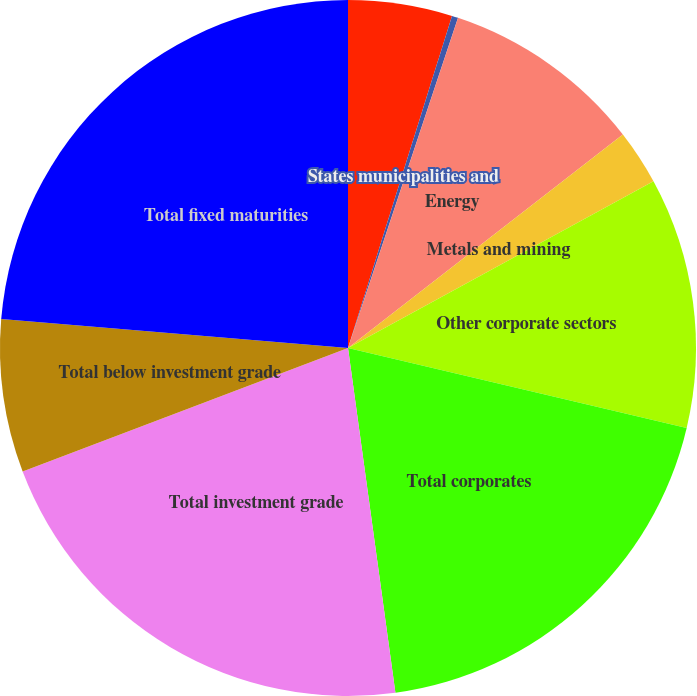Convert chart. <chart><loc_0><loc_0><loc_500><loc_500><pie_chart><fcel>US Government direct<fcel>States municipalities and<fcel>Energy<fcel>Metals and mining<fcel>Other corporate sectors<fcel>Total corporates<fcel>Total investment grade<fcel>Total below investment grade<fcel>Total fixed maturities<nl><fcel>4.83%<fcel>0.29%<fcel>9.37%<fcel>2.56%<fcel>11.64%<fcel>19.13%<fcel>21.4%<fcel>7.1%<fcel>23.67%<nl></chart> 